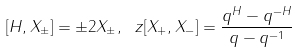Convert formula to latex. <formula><loc_0><loc_0><loc_500><loc_500>[ H , X _ { \pm } ] = \pm 2 X _ { \pm } , \ z [ X _ { + } , X _ { - } ] = \frac { q ^ { H } - q ^ { - H } } { q - q ^ { - 1 } }</formula> 